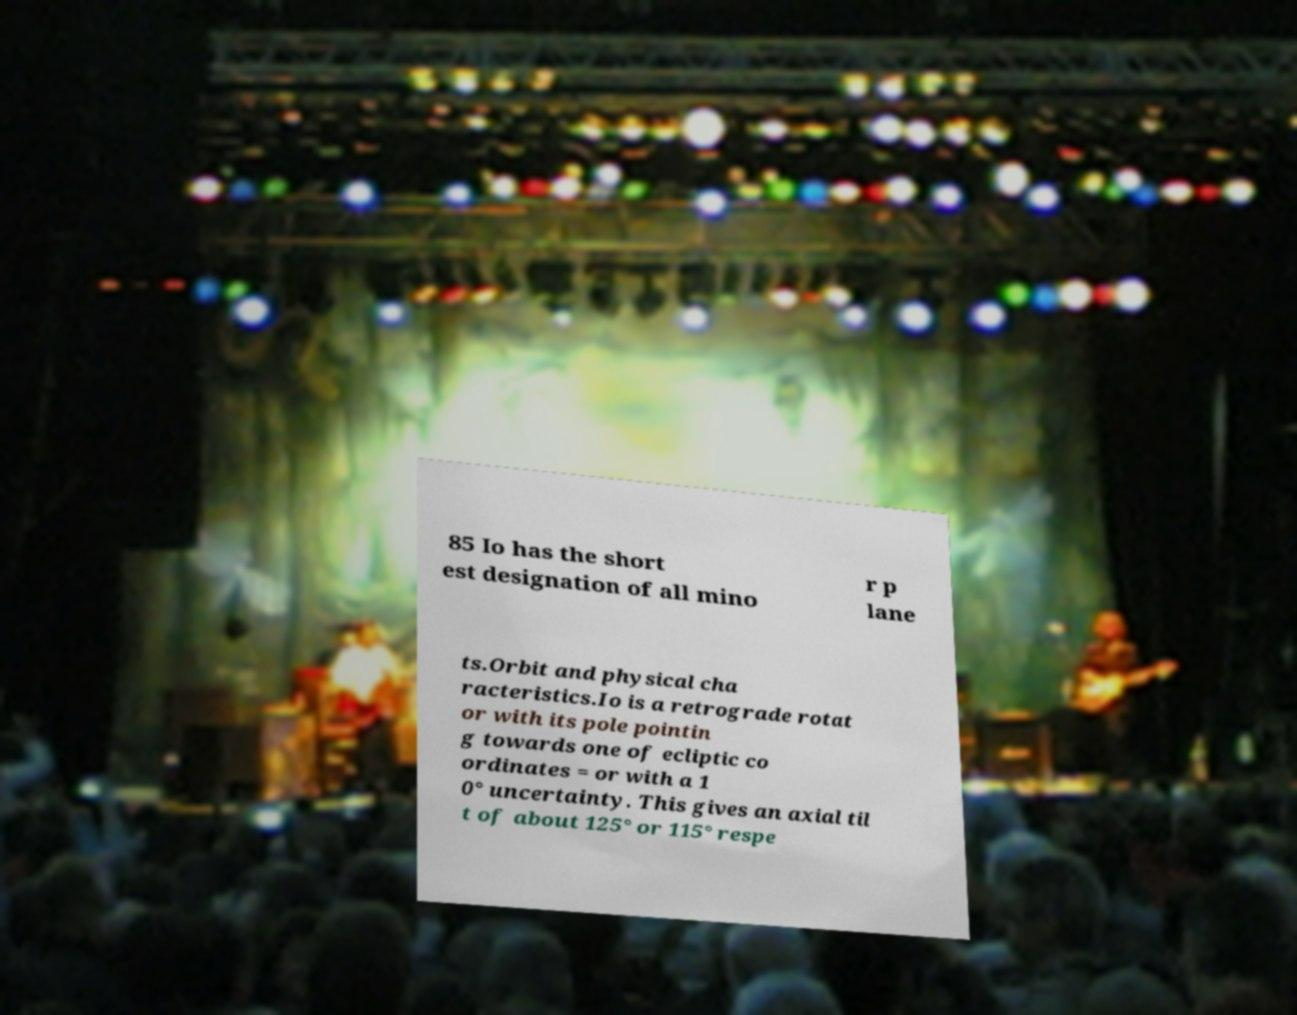For documentation purposes, I need the text within this image transcribed. Could you provide that? 85 Io has the short est designation of all mino r p lane ts.Orbit and physical cha racteristics.Io is a retrograde rotat or with its pole pointin g towards one of ecliptic co ordinates = or with a 1 0° uncertainty. This gives an axial til t of about 125° or 115° respe 